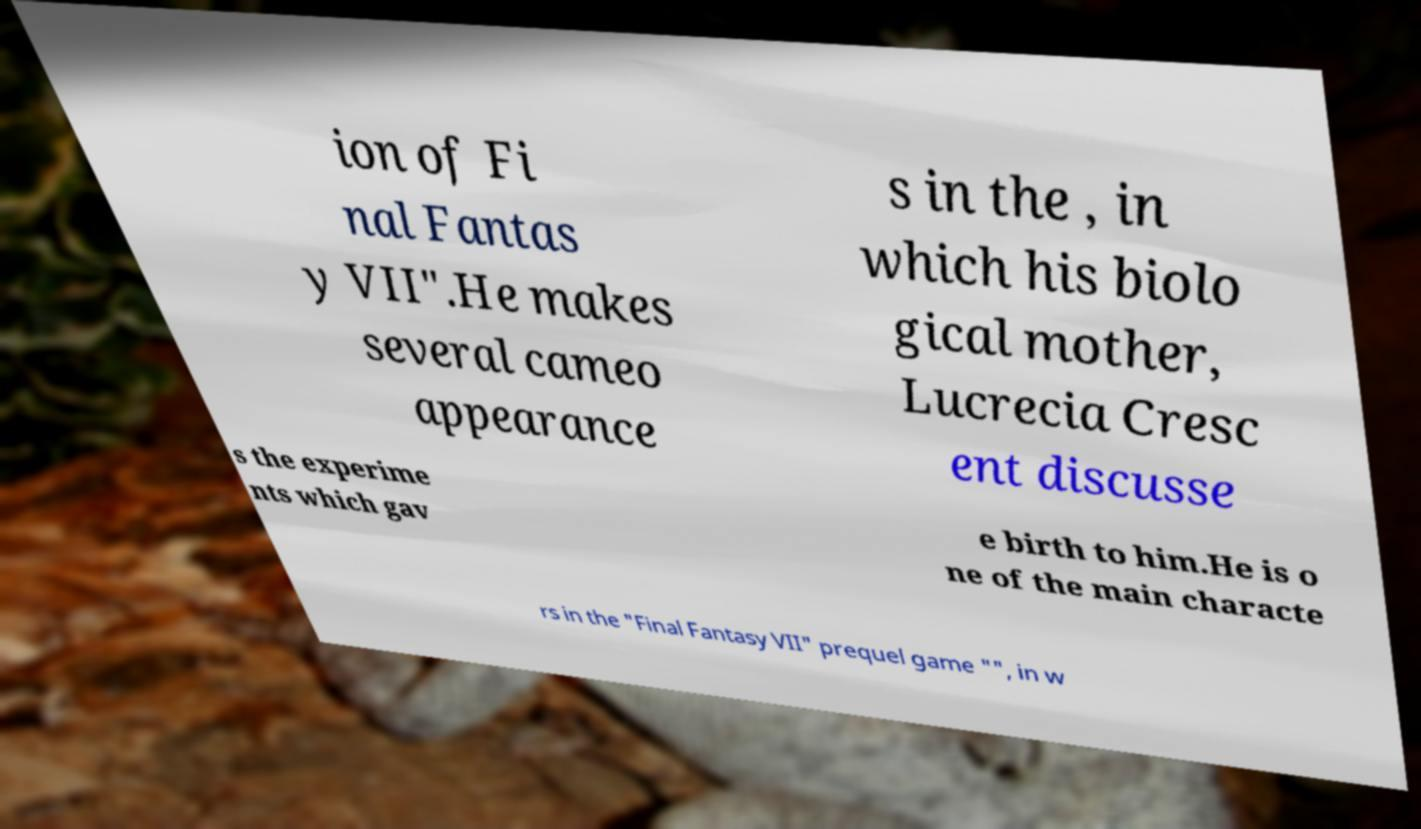I need the written content from this picture converted into text. Can you do that? ion of Fi nal Fantas y VII".He makes several cameo appearance s in the , in which his biolo gical mother, Lucrecia Cresc ent discusse s the experime nts which gav e birth to him.He is o ne of the main characte rs in the "Final Fantasy VII" prequel game "", in w 